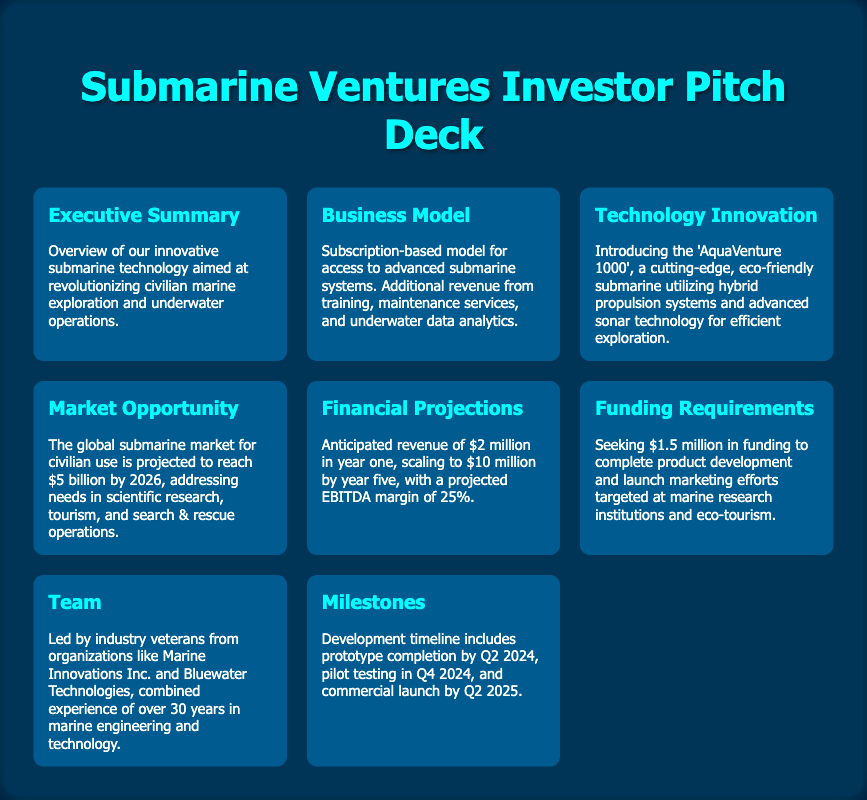What is the expected revenue in year one? The expected revenue in year one is mentioned in the Financial Projections section, which states it is $2 million.
Answer: $2 million What is the target market for the submarine technology? The Market Opportunity section highlights scientific research, tourism, and search & rescue operations as the target areas for the submarine technology.
Answer: Scientific research, tourism, search & rescue operations What is the funding requirement amount? The Funding Requirements section specifies that the venture is seeking $1.5 million in funding.
Answer: $1.5 million What is the name of the innovative submarine? The Technology Innovation section introduces the submarine as 'AquaVenture 1000'.
Answer: AquaVenture 1000 When is the commercial launch planned? The Milestones section outlines that the commercial launch is scheduled for Q2 2025.
Answer: Q2 2025 What is the projected EBITDA margin? The Financial Projections section outlines a projected EBITDA margin of 25%.
Answer: 25% What type of business model is being utilized? The Business Model section indicates a subscription-based model for the submarine technology.
Answer: Subscription-based model Who are the team leaders from the industry? The Team section mentions that the leaders have experience from Marine Innovations Inc. and Bluewater Technologies.
Answer: Marine Innovations Inc. and Bluewater Technologies What is the timeline for prototype completion? The Milestones section states that prototype completion is expected by Q2 2024.
Answer: Q2 2024 